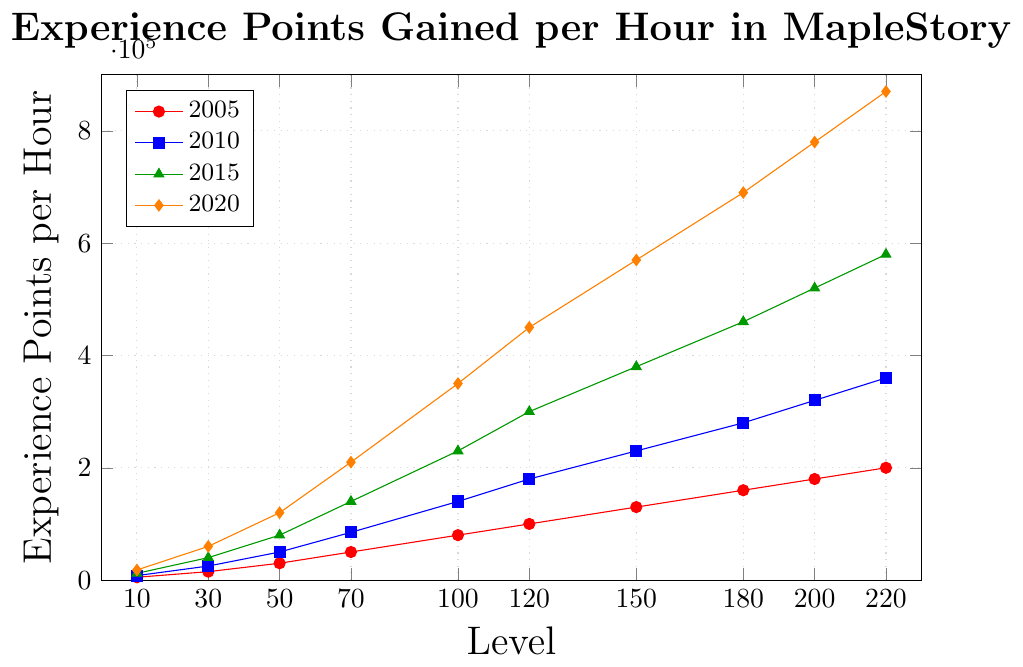What's the increase in experience points per hour for level 50 from 2005 to 2020? The experience points for level 50 in 2005 were 30,000, and in 2020 they were 120,000. The increase is calculated as 120,000 - 30,000 = 90,000.
Answer: 90,000 Which year shows the highest experience points per hour for level 100? From the chart, the experience points per hour for level 100 in 2020 are the highest at 350,000.
Answer: 2020 How does the experience points per hour for level 30 compare between 2010 and 2015? The experience points per hour for level 30 in 2010 is 25,000 and in 2015 is 40,000. Therefore, 2015 has higher experience points than 2010.
Answer: 2015 What's the total experience points gained per hour for level 150 in all the years shown? The experience points per hour for level 150 are 130,000 in 2005, 230,000 in 2010, 380,000 in 2015, and 570,000 in 2020. Summing these values: 130,000 + 230,000 + 380,000 + 570,000 = 1,310,000.
Answer: 1,310,000 What is the percentage increase in experience points per hour at level 200 from 2015 to 2020? The experience points per hour for level 200 in 2015 were 520,000 and in 2020 were 780,000. The percentage increase is calculated as ((780,000 - 520,000) / 520,000) * 100 = 50%.
Answer: 50% Between which two consecutive levels from 2005 does the experience points per hour increase the most? Calculating differences for each consecutive levels: (Level 30 - Level 10): 15,000 - 5,000 = 10,000; (Level 50 - Level 30): 30,000 - 15,000 = 15,000; (Level 70 - Level 50): 50,000 - 30,000 = 20,000; (Level 100 - Level 70): 80,000 - 50,000 = 30,000; (Level 120 - Level 100): 100,000 - 80,000 = 20,000; (Level 150 - Level 120): 130,000 - 100,000 = 30,000; (Level 180 - Level 150): 160,000 - 130,000 = 30,000; (Level 200 - Level 180): 180,000 - 160,000 = 20,000; (Level 220 - Level 200): 200,000 - 180,000 = 20,000. The highest increase is between Level 100 and Level 70.
Answer: Level 100 and Level 70 What is the average experience points per hour at level 220 across all the years provided? The experience points per hour for level 220 are 200,000 in 2005, 360,000 in 2010, 580,000 in 2015, and 870,000 in 2020. The average is calculated as (200,000 + 360,000 + 580,000 + 870,000) / 4 = 502,500.
Answer: 502,500 Do the experience points per hour for level 120 in 2020 exceed the total experience points per hour for level 100 in 2010 and 2015 combined? For level 100, the experience points are 140,000 in 2010 and 230,000 in 2015, totaling 370,000. For level 120 in 2020, the experience points are 450,000. 450,000 exceeds 370,000.
Answer: Yes 